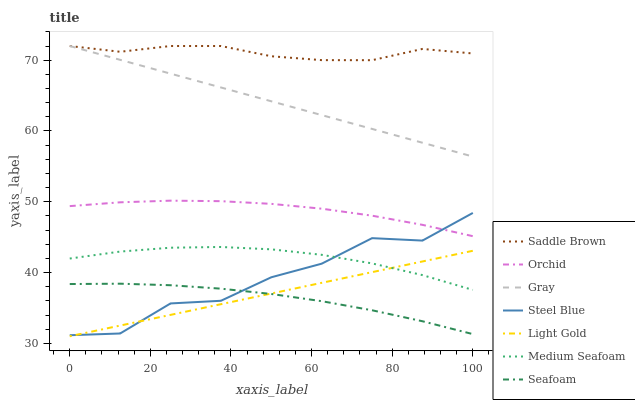Does Seafoam have the minimum area under the curve?
Answer yes or no. Yes. Does Saddle Brown have the maximum area under the curve?
Answer yes or no. Yes. Does Steel Blue have the minimum area under the curve?
Answer yes or no. No. Does Steel Blue have the maximum area under the curve?
Answer yes or no. No. Is Light Gold the smoothest?
Answer yes or no. Yes. Is Steel Blue the roughest?
Answer yes or no. Yes. Is Seafoam the smoothest?
Answer yes or no. No. Is Seafoam the roughest?
Answer yes or no. No. Does Light Gold have the lowest value?
Answer yes or no. Yes. Does Seafoam have the lowest value?
Answer yes or no. No. Does Saddle Brown have the highest value?
Answer yes or no. Yes. Does Steel Blue have the highest value?
Answer yes or no. No. Is Light Gold less than Saddle Brown?
Answer yes or no. Yes. Is Gray greater than Medium Seafoam?
Answer yes or no. Yes. Does Saddle Brown intersect Gray?
Answer yes or no. Yes. Is Saddle Brown less than Gray?
Answer yes or no. No. Is Saddle Brown greater than Gray?
Answer yes or no. No. Does Light Gold intersect Saddle Brown?
Answer yes or no. No. 